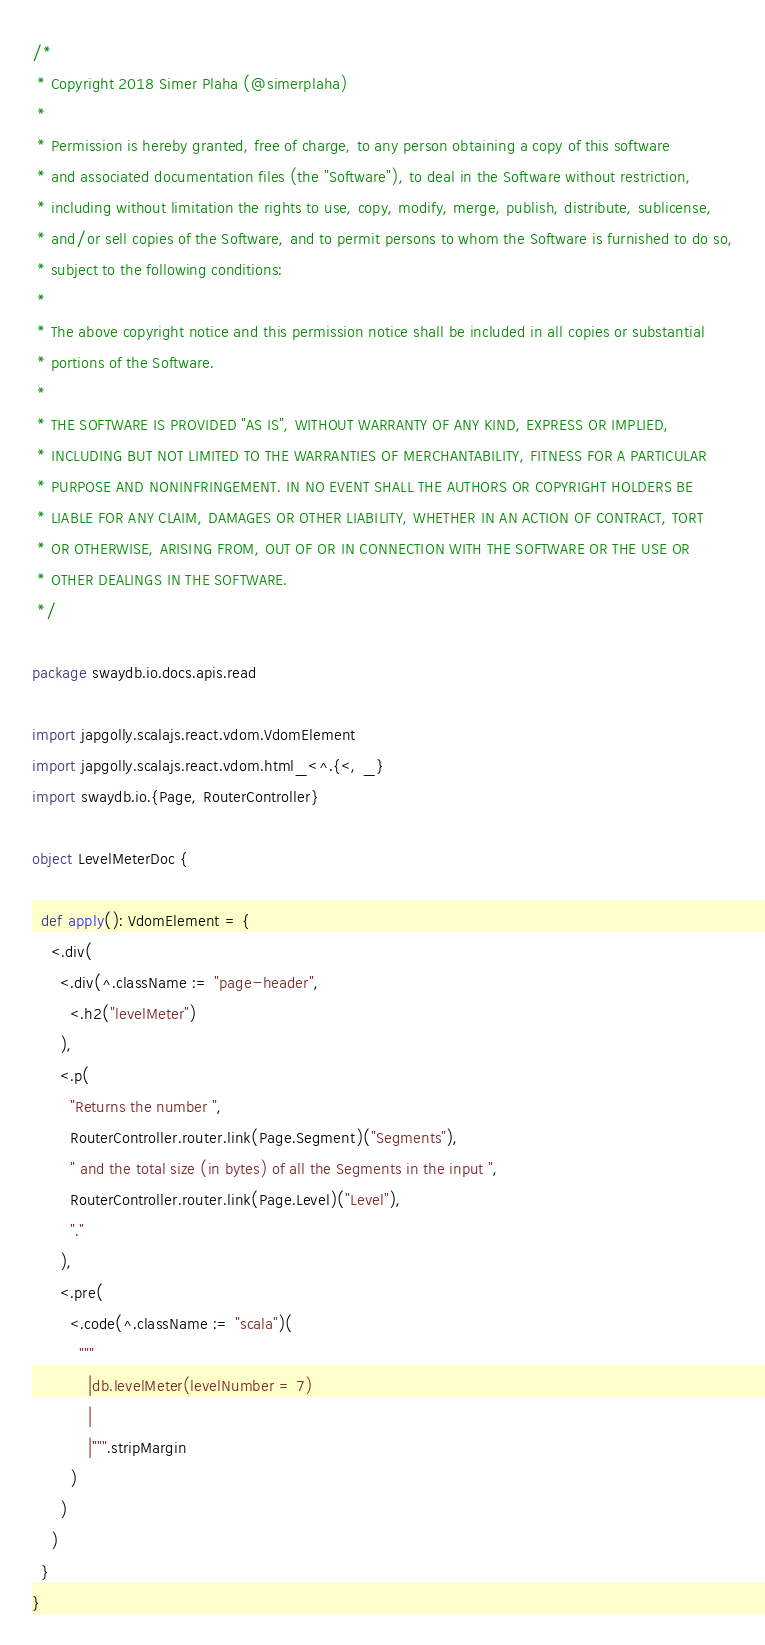Convert code to text. <code><loc_0><loc_0><loc_500><loc_500><_Scala_>/*
 * Copyright 2018 Simer Plaha (@simerplaha)
 *
 * Permission is hereby granted, free of charge, to any person obtaining a copy of this software
 * and associated documentation files (the "Software"), to deal in the Software without restriction,
 * including without limitation the rights to use, copy, modify, merge, publish, distribute, sublicense,
 * and/or sell copies of the Software, and to permit persons to whom the Software is furnished to do so,
 * subject to the following conditions:
 *
 * The above copyright notice and this permission notice shall be included in all copies or substantial
 * portions of the Software.
 *
 * THE SOFTWARE IS PROVIDED "AS IS", WITHOUT WARRANTY OF ANY KIND, EXPRESS OR IMPLIED,
 * INCLUDING BUT NOT LIMITED TO THE WARRANTIES OF MERCHANTABILITY, FITNESS FOR A PARTICULAR
 * PURPOSE AND NONINFRINGEMENT. IN NO EVENT SHALL THE AUTHORS OR COPYRIGHT HOLDERS BE
 * LIABLE FOR ANY CLAIM, DAMAGES OR OTHER LIABILITY, WHETHER IN AN ACTION OF CONTRACT, TORT
 * OR OTHERWISE, ARISING FROM, OUT OF OR IN CONNECTION WITH THE SOFTWARE OR THE USE OR
 * OTHER DEALINGS IN THE SOFTWARE.
 */

package swaydb.io.docs.apis.read

import japgolly.scalajs.react.vdom.VdomElement
import japgolly.scalajs.react.vdom.html_<^.{<, _}
import swaydb.io.{Page, RouterController}

object LevelMeterDoc {

  def apply(): VdomElement = {
    <.div(
      <.div(^.className := "page-header",
        <.h2("levelMeter")
      ),
      <.p(
        "Returns the number ",
        RouterController.router.link(Page.Segment)("Segments"),
        " and the total size (in bytes) of all the Segments in the input ",
        RouterController.router.link(Page.Level)("Level"),
        "."
      ),
      <.pre(
        <.code(^.className := "scala")(
          """
            |db.levelMeter(levelNumber = 7)
            |
            |""".stripMargin
        )
      )
    )
  }
}
</code> 